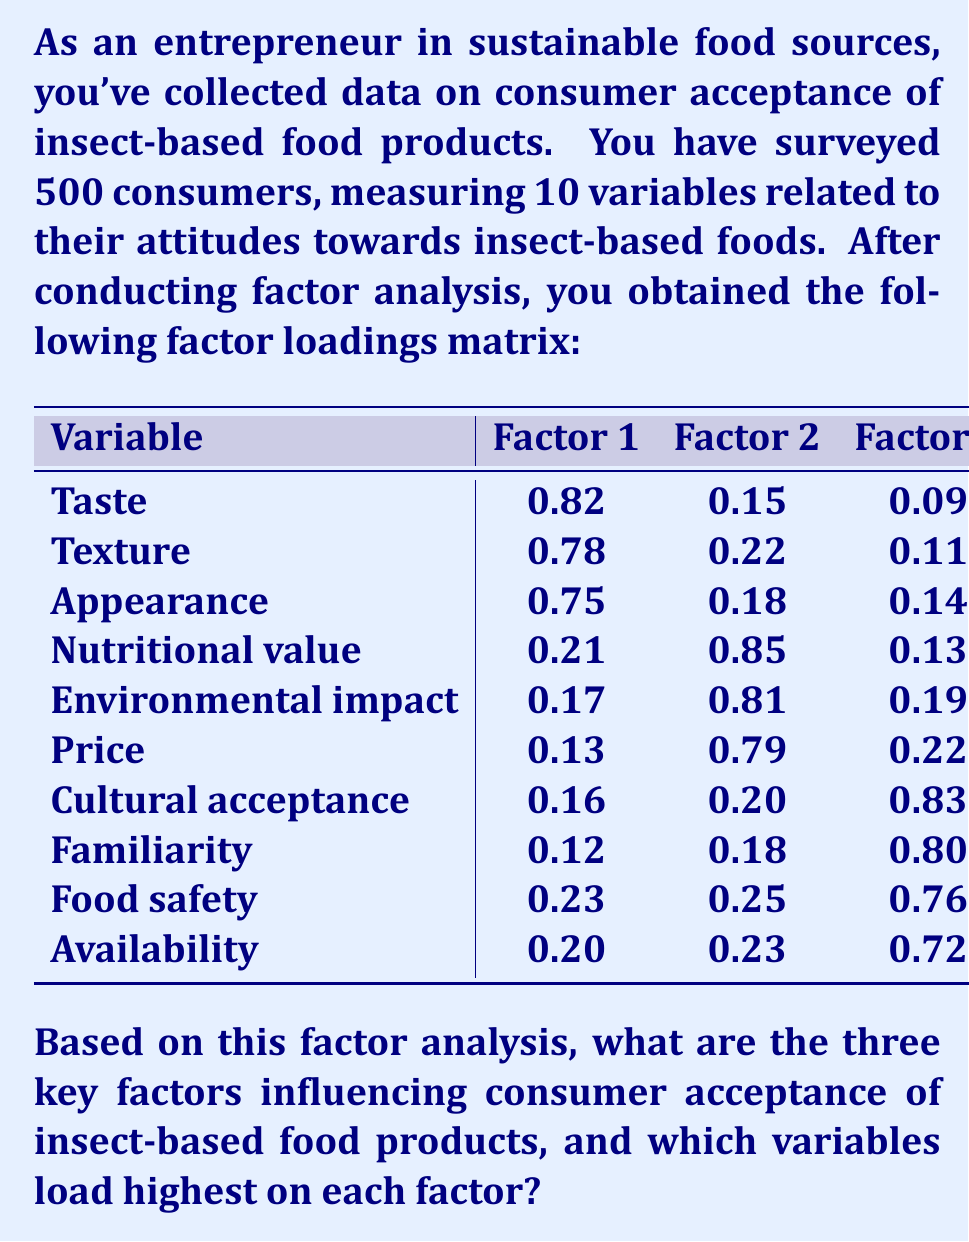Can you solve this math problem? To interpret the results of the factor analysis and identify the key factors influencing consumer acceptance of insect-based food products, we need to follow these steps:

1. Examine the factor loadings matrix:
   The matrix shows how each variable correlates with each factor. Higher absolute values indicate stronger relationships.

2. Identify variables with high loadings on each factor:
   We typically consider loadings above 0.7 as high.

3. Interpret and name each factor based on the variables that load highly on it:

   Factor 1:
   - Taste (0.82)
   - Texture (0.78)
   - Appearance (0.75)
   These variables relate to sensory characteristics, so we can name this factor "Sensory Appeal."

   Factor 2:
   - Nutritional value (0.85)
   - Environmental impact (0.81)
   - Price (0.79)
   These variables relate to practical and ethical considerations, so we can name this factor "Practical and Ethical Considerations."

   Factor 3:
   - Cultural acceptance (0.83)
   - Familiarity (0.80)
   - Food safety (0.76)
   - Availability (0.72)
   These variables relate to societal and personal comfort levels, so we can name this factor "Social and Personal Acceptance."

4. Identify the variables that load highest on each factor:
   - Factor 1 (Sensory Appeal): Taste (0.82)
   - Factor 2 (Practical and Ethical Considerations): Nutritional value (0.85)
   - Factor 3 (Social and Personal Acceptance): Cultural acceptance (0.83)

These three factors represent the key dimensions influencing consumer acceptance of insect-based food products.
Answer: The three key factors are: 1) Sensory Appeal, 2) Practical and Ethical Considerations, and 3) Social and Personal Acceptance. The highest loading variables are: Taste (Factor 1), Nutritional value (Factor 2), and Cultural acceptance (Factor 3). 